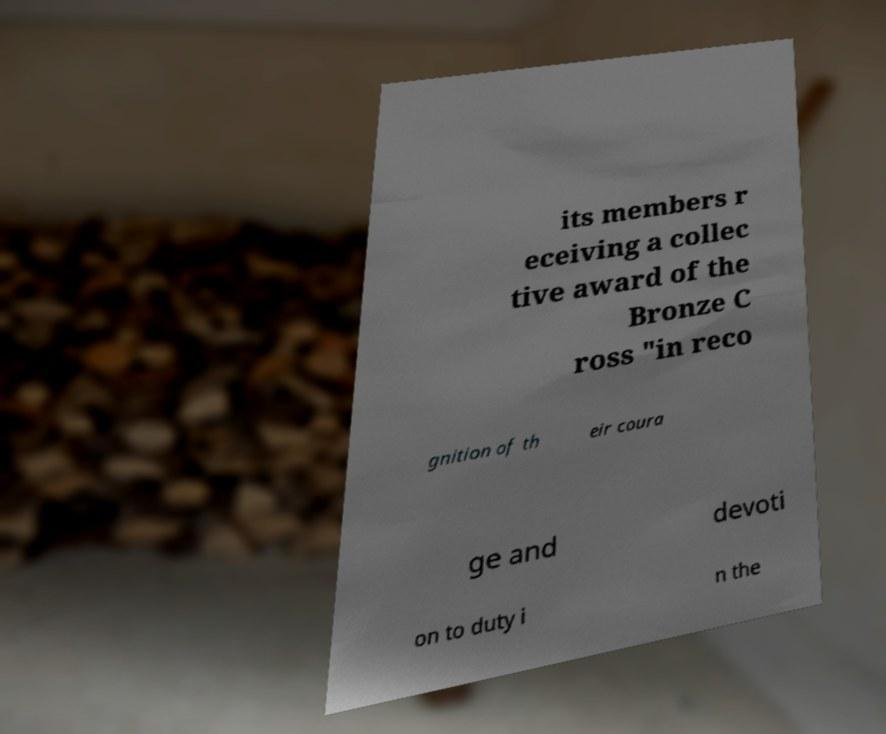Could you assist in decoding the text presented in this image and type it out clearly? its members r eceiving a collec tive award of the Bronze C ross "in reco gnition of th eir coura ge and devoti on to duty i n the 